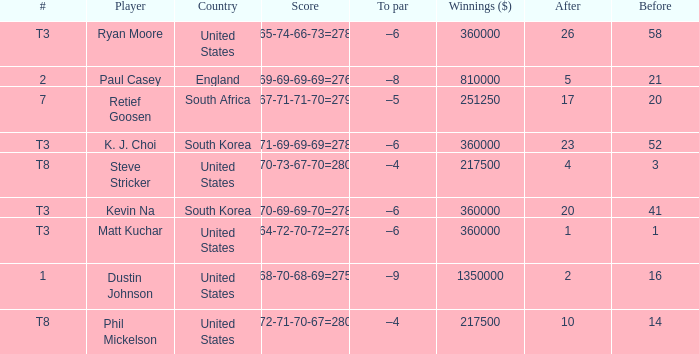What is the player listed when the score is 68-70-68-69=275 Dustin Johnson. Write the full table. {'header': ['#', 'Player', 'Country', 'Score', 'To par', 'Winnings ($)', 'After', 'Before'], 'rows': [['T3', 'Ryan Moore', 'United States', '65-74-66-73=278', '–6', '360000', '26', '58'], ['2', 'Paul Casey', 'England', '69-69-69-69=276', '–8', '810000', '5', '21'], ['7', 'Retief Goosen', 'South Africa', '67-71-71-70=279', '–5', '251250', '17', '20'], ['T3', 'K. J. Choi', 'South Korea', '71-69-69-69=278', '–6', '360000', '23', '52'], ['T8', 'Steve Stricker', 'United States', '70-73-67-70=280', '–4', '217500', '4', '3'], ['T3', 'Kevin Na', 'South Korea', '70-69-69-70=278', '–6', '360000', '20', '41'], ['T3', 'Matt Kuchar', 'United States', '64-72-70-72=278', '–6', '360000', '1', '1'], ['1', 'Dustin Johnson', 'United States', '68-70-68-69=275', '–9', '1350000', '2', '16'], ['T8', 'Phil Mickelson', 'United States', '72-71-70-67=280', '–4', '217500', '10', '14']]} 